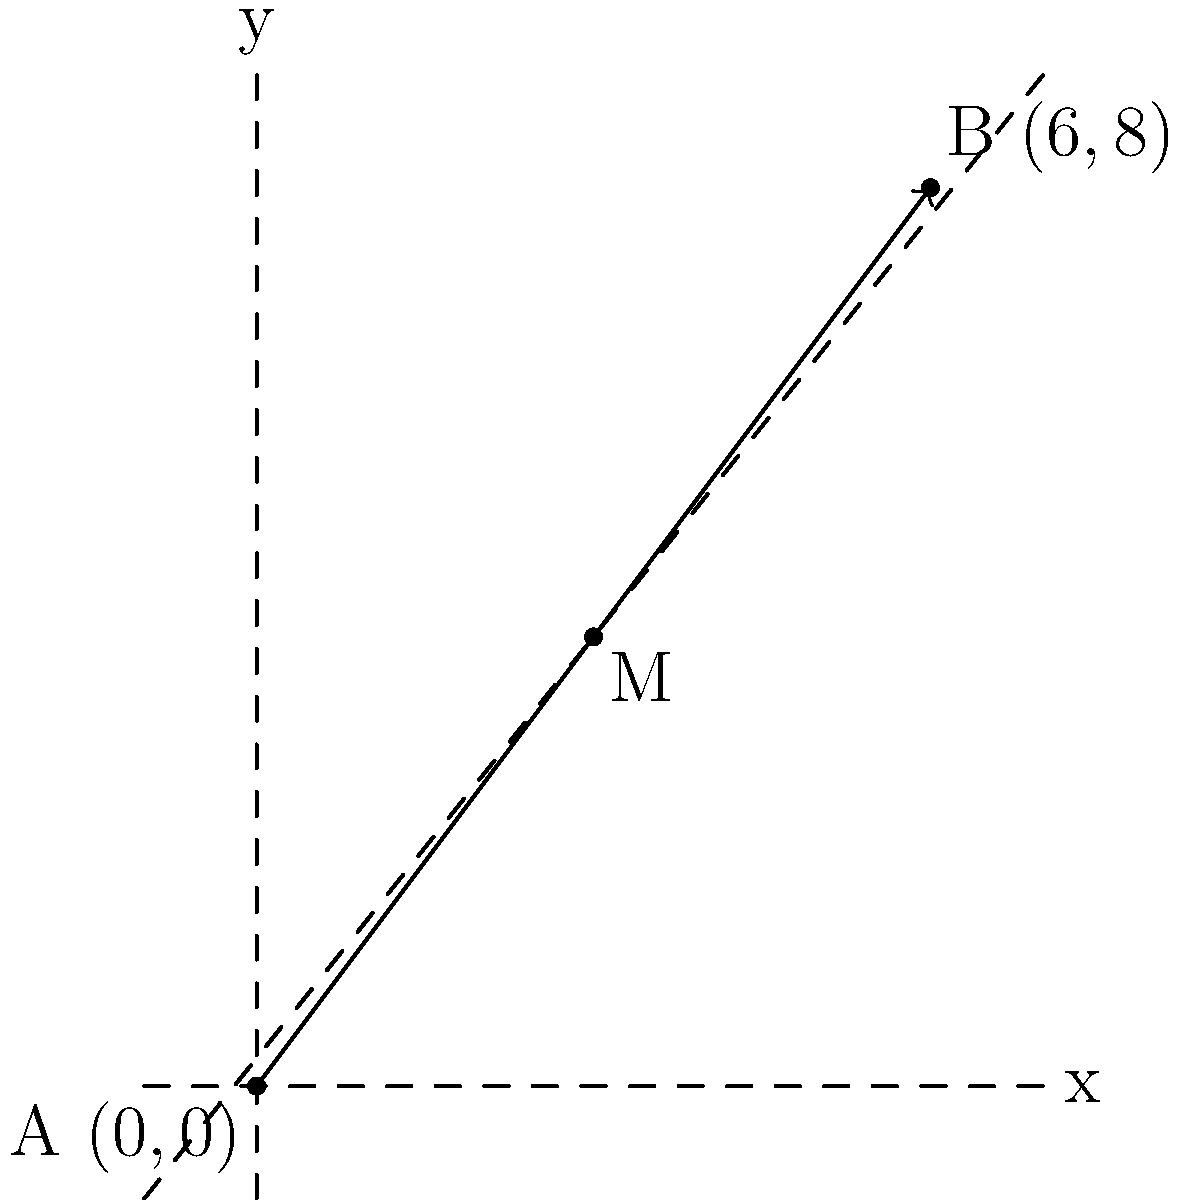In a neurofeedback therapy session, two electrodes are placed at points A(0,0) and B(6,8) on a patient's scalp. To optimize the therapy, a third electrode needs to be placed at the midpoint of the line segment connecting these two electrodes. What are the coordinates of this midpoint M? To find the midpoint of a line segment, we can use the midpoint formula:

$$ M_x = \frac{x_1 + x_2}{2}, \quad M_y = \frac{y_1 + y_2}{2} $$

Where $(x_1, y_1)$ are the coordinates of point A, and $(x_2, y_2)$ are the coordinates of point B.

Step 1: Identify the coordinates
A: $(x_1, y_1) = (0, 0)$
B: $(x_2, y_2) = (6, 8)$

Step 2: Calculate the x-coordinate of the midpoint
$$ M_x = \frac{x_1 + x_2}{2} = \frac{0 + 6}{2} = \frac{6}{2} = 3 $$

Step 3: Calculate the y-coordinate of the midpoint
$$ M_y = \frac{y_1 + y_2}{2} = \frac{0 + 8}{2} = \frac{8}{2} = 4 $$

Therefore, the coordinates of the midpoint M are (3, 4).
Answer: (3, 4) 